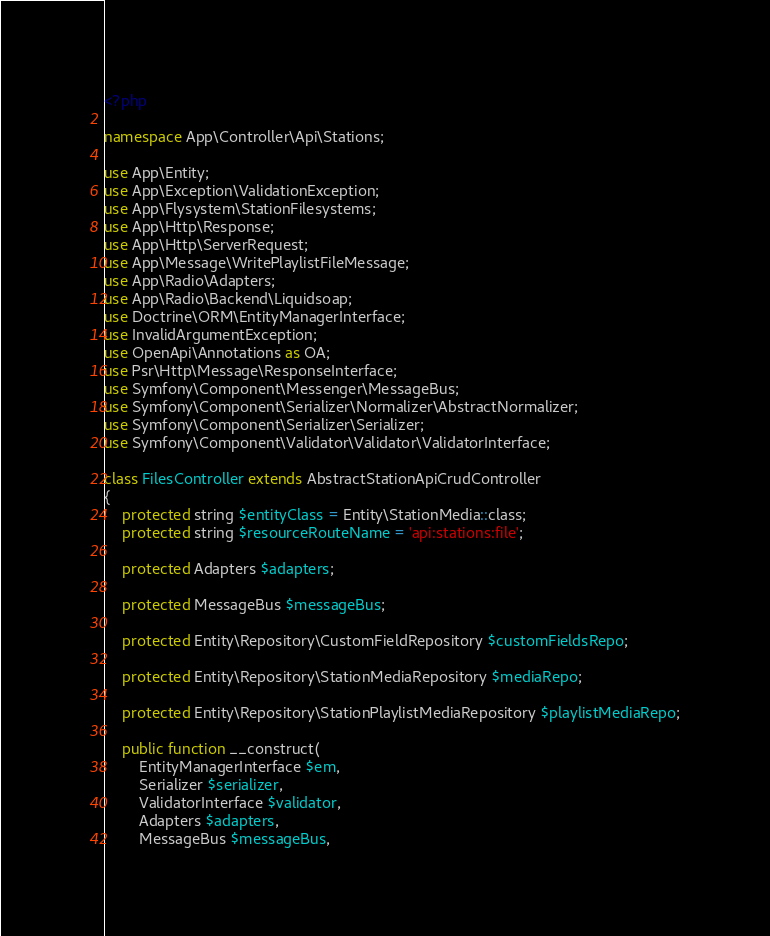<code> <loc_0><loc_0><loc_500><loc_500><_PHP_><?php

namespace App\Controller\Api\Stations;

use App\Entity;
use App\Exception\ValidationException;
use App\Flysystem\StationFilesystems;
use App\Http\Response;
use App\Http\ServerRequest;
use App\Message\WritePlaylistFileMessage;
use App\Radio\Adapters;
use App\Radio\Backend\Liquidsoap;
use Doctrine\ORM\EntityManagerInterface;
use InvalidArgumentException;
use OpenApi\Annotations as OA;
use Psr\Http\Message\ResponseInterface;
use Symfony\Component\Messenger\MessageBus;
use Symfony\Component\Serializer\Normalizer\AbstractNormalizer;
use Symfony\Component\Serializer\Serializer;
use Symfony\Component\Validator\Validator\ValidatorInterface;

class FilesController extends AbstractStationApiCrudController
{
    protected string $entityClass = Entity\StationMedia::class;
    protected string $resourceRouteName = 'api:stations:file';

    protected Adapters $adapters;

    protected MessageBus $messageBus;

    protected Entity\Repository\CustomFieldRepository $customFieldsRepo;

    protected Entity\Repository\StationMediaRepository $mediaRepo;

    protected Entity\Repository\StationPlaylistMediaRepository $playlistMediaRepo;

    public function __construct(
        EntityManagerInterface $em,
        Serializer $serializer,
        ValidatorInterface $validator,
        Adapters $adapters,
        MessageBus $messageBus,</code> 